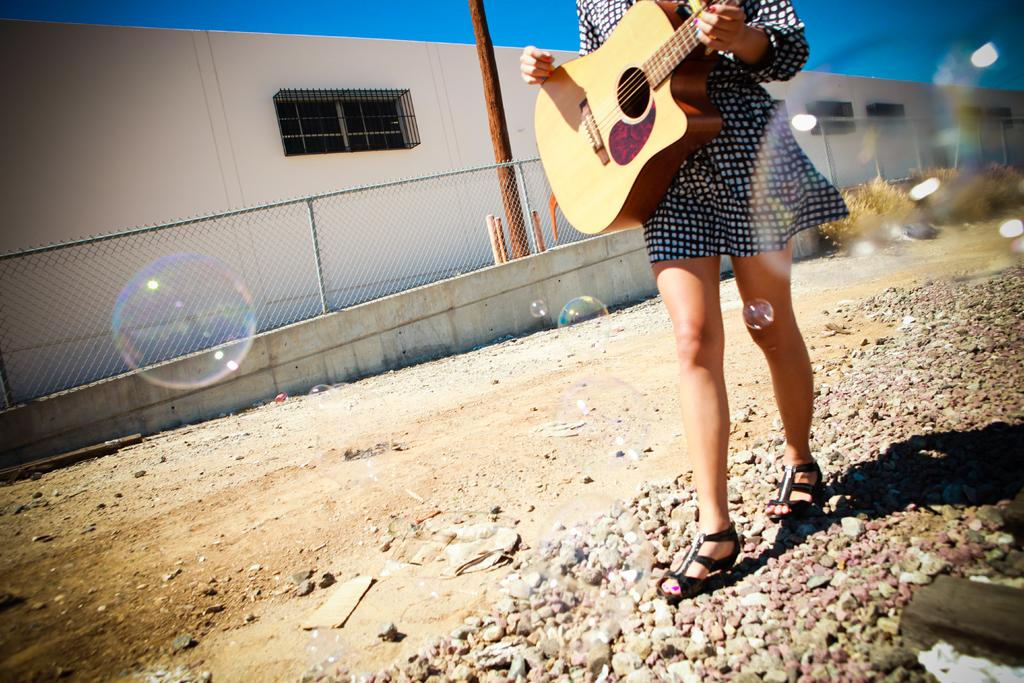Who is the main subject in the image? There is a woman in the image. What is the woman holding in the image? The woman is holding a guitar. What is the woman doing in the image? The woman is walking. What else can be seen in the image besides the woman? There are air bubbles and a house visible in the image. What type of instrument can be seen growing in the bushes in the image? There are no bushes or instruments growing in the image; it features a woman walking with a guitar. 